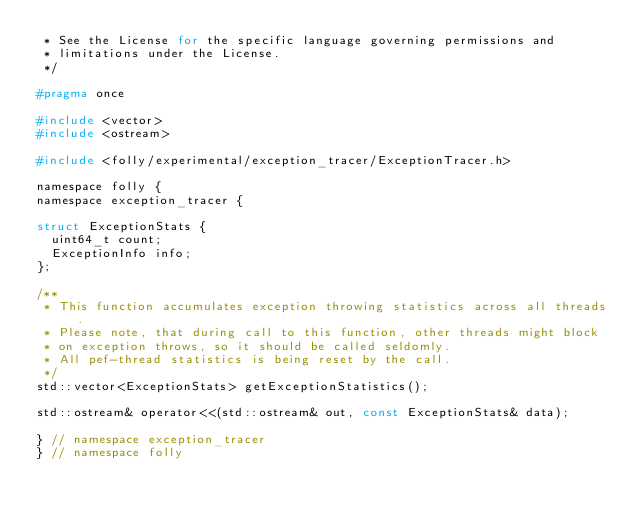<code> <loc_0><loc_0><loc_500><loc_500><_C_> * See the License for the specific language governing permissions and
 * limitations under the License.
 */

#pragma once

#include <vector>
#include <ostream>

#include <folly/experimental/exception_tracer/ExceptionTracer.h>

namespace folly {
namespace exception_tracer {

struct ExceptionStats {
  uint64_t count;
  ExceptionInfo info;
};

/**
 * This function accumulates exception throwing statistics across all threads.
 * Please note, that during call to this function, other threads might block
 * on exception throws, so it should be called seldomly.
 * All pef-thread statistics is being reset by the call.
 */
std::vector<ExceptionStats> getExceptionStatistics();

std::ostream& operator<<(std::ostream& out, const ExceptionStats& data);

} // namespace exception_tracer
} // namespace folly
</code> 